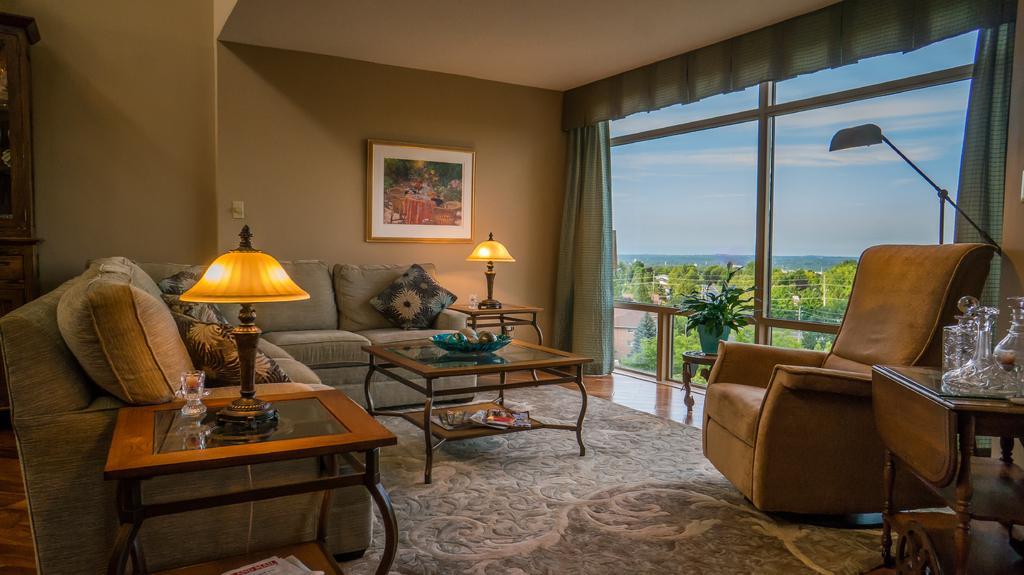How would you summarize this image in a sentence or two? In this picture we can see a room with sofa pillow on it and aside to that and in front of that there are tables and on table we can see lamp, bowl and in background we can see wall with frame, window with curtain, some glass items, flower pot with plant in it, trees, sky. 